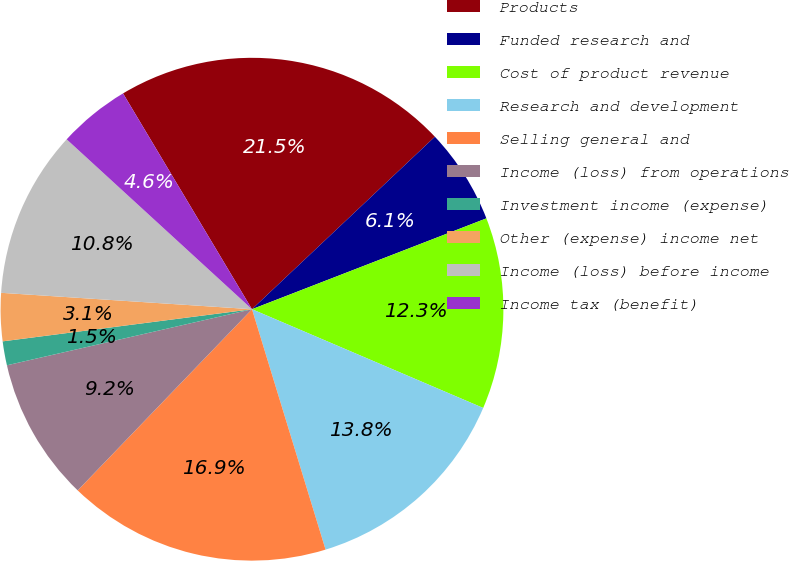<chart> <loc_0><loc_0><loc_500><loc_500><pie_chart><fcel>Products<fcel>Funded research and<fcel>Cost of product revenue<fcel>Research and development<fcel>Selling general and<fcel>Income (loss) from operations<fcel>Investment income (expense)<fcel>Other (expense) income net<fcel>Income (loss) before income<fcel>Income tax (benefit)<nl><fcel>21.54%<fcel>6.15%<fcel>12.31%<fcel>13.85%<fcel>16.92%<fcel>9.23%<fcel>1.54%<fcel>3.08%<fcel>10.77%<fcel>4.62%<nl></chart> 